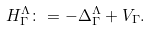Convert formula to latex. <formula><loc_0><loc_0><loc_500><loc_500>H _ { \Gamma } ^ { \Lambda } \colon = - \Delta _ { \Gamma } ^ { \Lambda } + V _ { \Gamma } .</formula> 